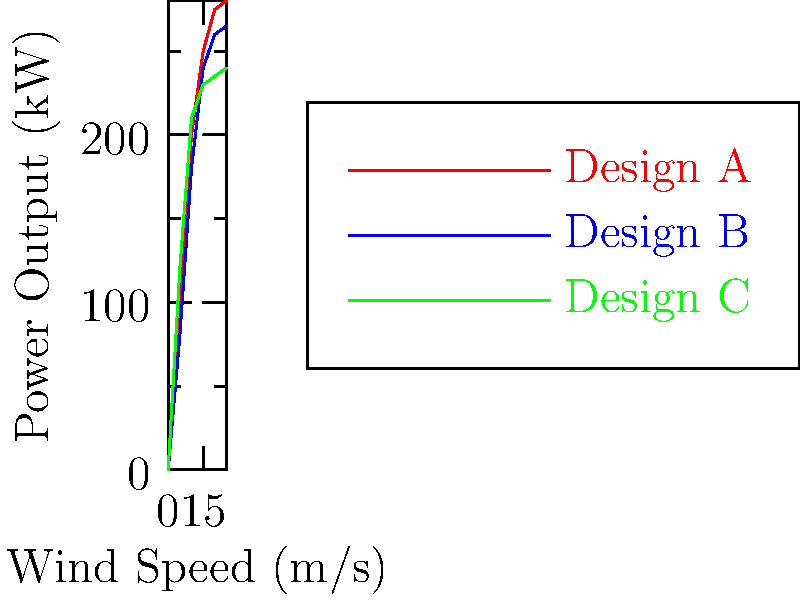As a journalist covering renewable energy innovations, you're analyzing data on wind turbine efficiency. The graph shows power output for three different blade designs (A, B, and C) across various wind speeds. Which design appears to be most efficient at lower wind speeds (below 10 m/s), and how might this relate to the broader discussion on adapting renewable technologies for diverse environmental conditions? To answer this question, we need to analyze the graph and interpret the data in the context of wind turbine efficiency and environmental adaptability. Let's break it down step-by-step:

1. Examine the graph:
   - The x-axis represents wind speed in m/s
   - The y-axis represents power output in kW
   - Three lines represent different blade designs: A (red), B (blue), and C (green)

2. Focus on lower wind speeds (below 10 m/s):
   - At 5 m/s: Design C (green) has the highest output
   - At 10 m/s: Design C still maintains the highest output

3. Compare the slopes of the lines:
   - Design C has the steepest slope in the 0-10 m/s range
   - This indicates it generates more power at lower wind speeds

4. Interpret the results:
   - Design C is most efficient at lower wind speeds
   - This suggests it can generate more power in areas with generally lower wind speeds

5. Relate to broader environmental discussions:
   - Different regions have varying wind patterns
   - Adapting turbine designs to specific conditions can optimize energy production
   - Design C could be beneficial in areas with consistently lower wind speeds

6. Consider the implications:
   - Customizing turbine designs for local conditions can increase overall efficiency
   - This approach aligns with the need for versatile renewable energy solutions
   - It demonstrates the importance of tailored engineering in addressing climate change
Answer: Design C; it's most efficient at lower wind speeds, highlighting the importance of adapting renewable technologies to diverse environmental conditions. 